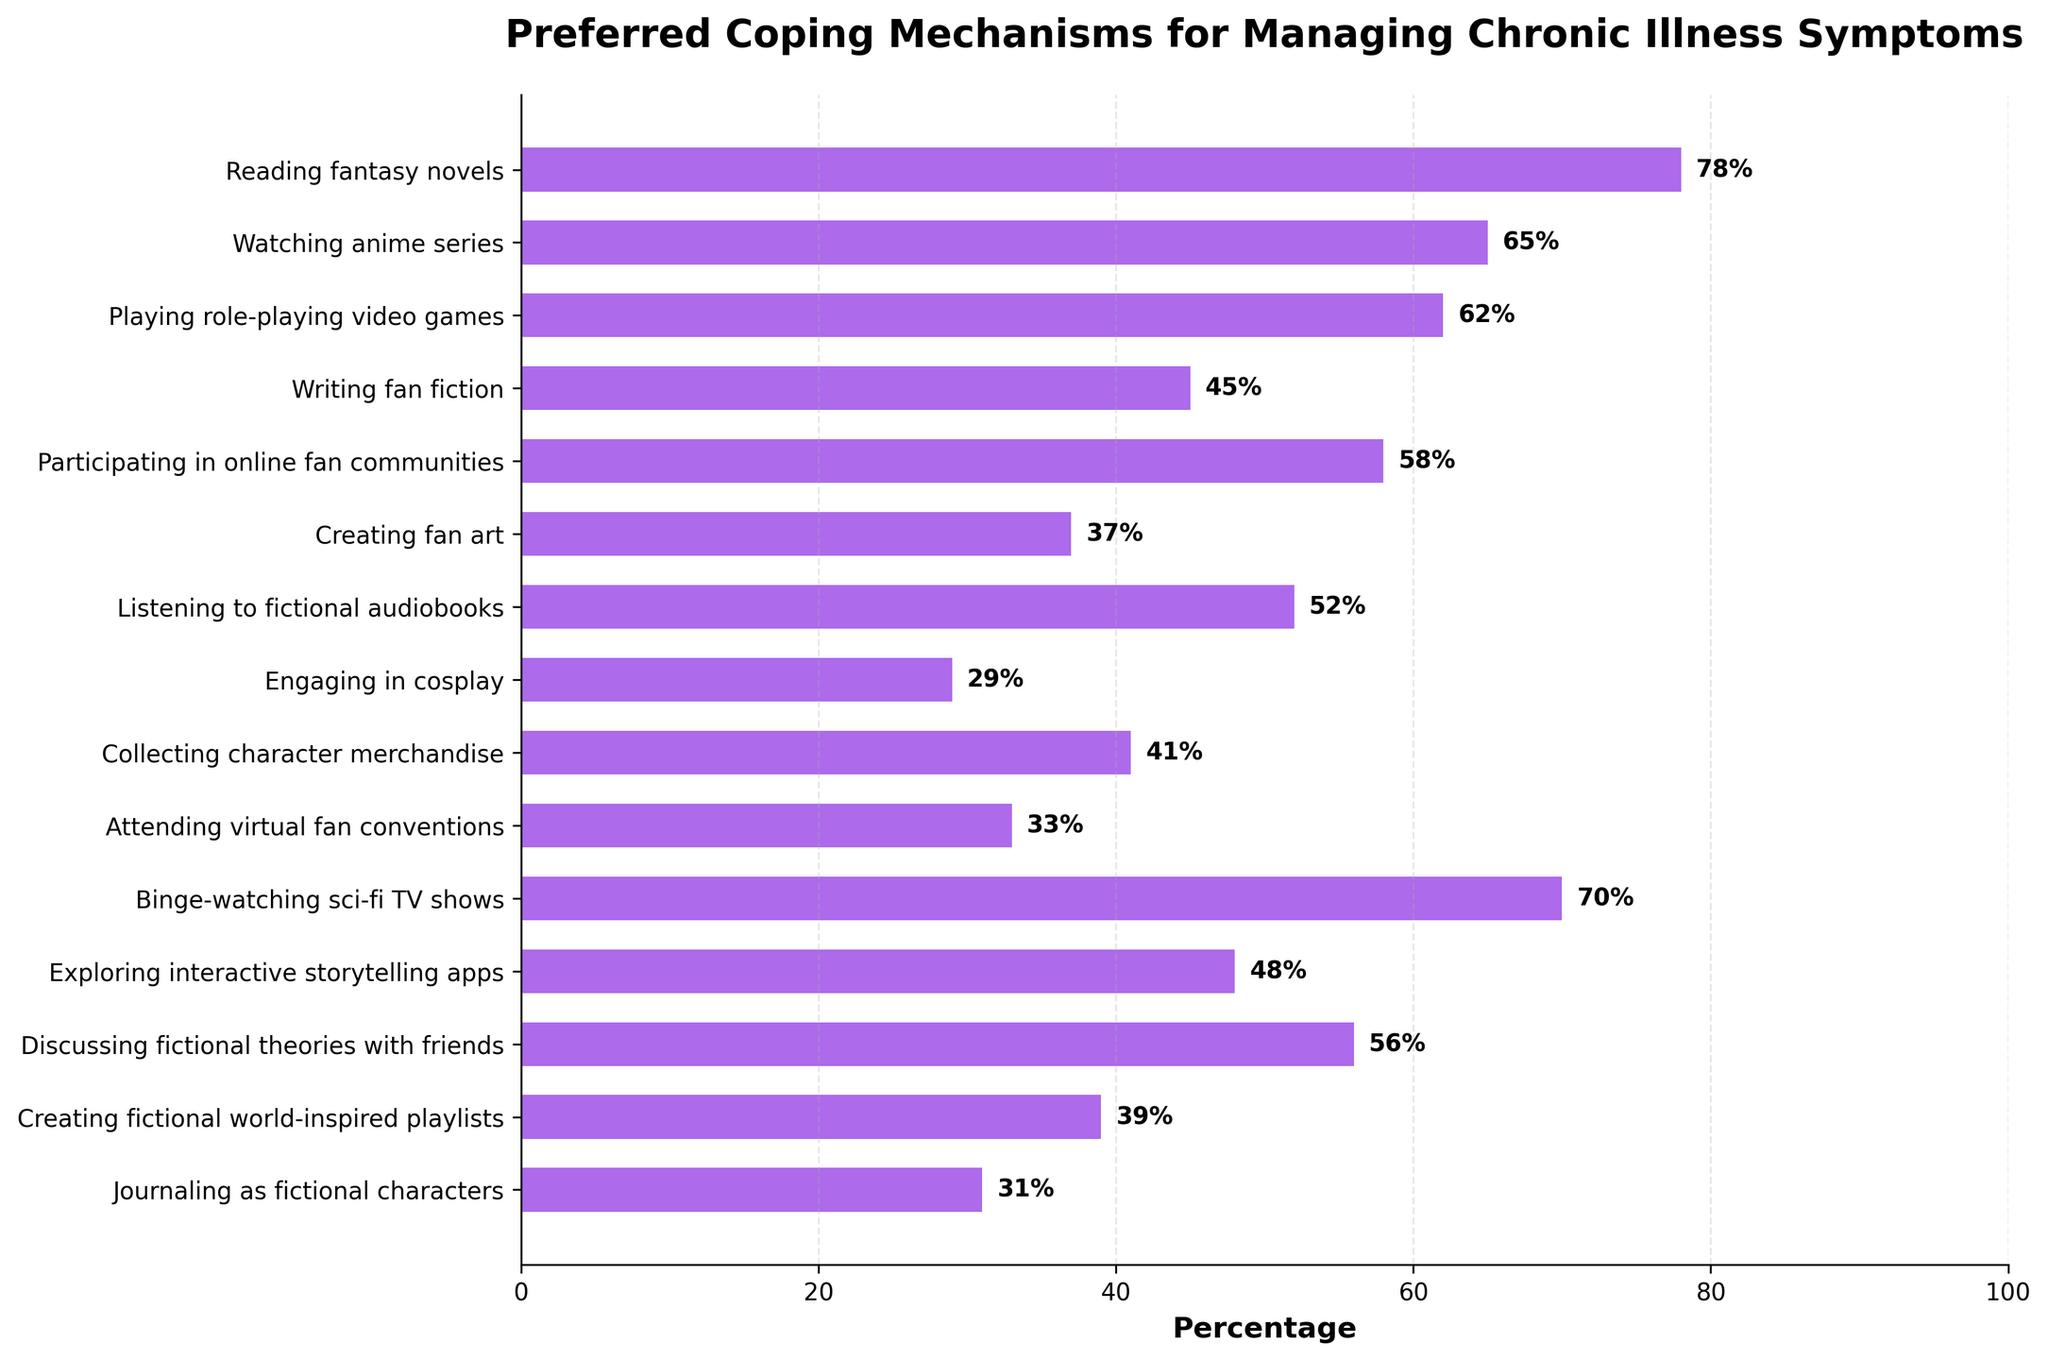Which coping mechanism has the highest percentage? The bar corresponding to "Reading fantasy novels" is the longest and reaches 78%, indicating it has the highest percentage.
Answer: Reading fantasy novels Which coping mechanism has the lowest percentage? The bar for "Engaging in cosplay" is the shortest, at 29%, indicating it has the lowest percentage.
Answer: Engaging in cosplay How many coping mechanisms have percentages greater than 50%? From the plot, the bars for "Reading fantasy novels," "Watching anime series," "Playing role-playing video games," "Binge-watching sci-fi TV shows," "Listening to fictional audiobooks," "Participating in online fan communities," and "Discussing fictional theories with friends" are greater than 50%. Counting these bars gives us 7.
Answer: 7 Which coping mechanism has a percentage closest to the average percentage of all coping mechanisms? First, calculate the average percentage: (78 + 65 + 62 + 45 + 58 + 37 + 52 + 29 + 41 + 33 + 70 + 48 + 56 + 39 + 31) / 15 = 49. Then, identify the bar closest to 49%, which is "Exploring interactive storytelling apps" at 48%.
Answer: Exploring interactive storytelling apps What is the difference in percentage between "Binge-watching sci-fi TV shows" and "Collecting character merchandise"? The percentage for "Binge-watching sci-fi TV shows" is 70%, and for "Collecting character merchandise," it is 41%. The difference is 70 - 41 = 29.
Answer: 29 Compare the percentage of "Watching anime series" with "Writing fan fiction." Which one is higher and by how much? "Watching anime series" has a percentage of 65%, while "Writing fan fiction" has a percentage of 45%. The difference is 65 - 45 = 20, with "Watching anime series" being higher.
Answer: Watching anime series by 20 What are the top three preferred coping mechanisms? The top three longest bars belong to "Reading fantasy novels" (78%), "Binge-watching sci-fi TV shows" (70%), and "Watching anime series" (65%).
Answer: Reading fantasy novels, Binge-watching sci-fi TV shows, Watching anime series What is the combined percentage of "Playing role-playing video games" and "Creating fan art"? The percentage of "Playing role-playing video games" is 62%, and "Creating fan art" is 37%. The combined percentage is 62 + 37 = 99.
Answer: 99 What percentage difference exists between "Creating fictional world-inspired playlists" and "Journaling as fictional characters"? The percentage for "Creating fictional world-inspired playlists" is 39%, and for "Journaling as fictional characters," it is 31%. The difference is 39 - 31 = 8.
Answer: 8 